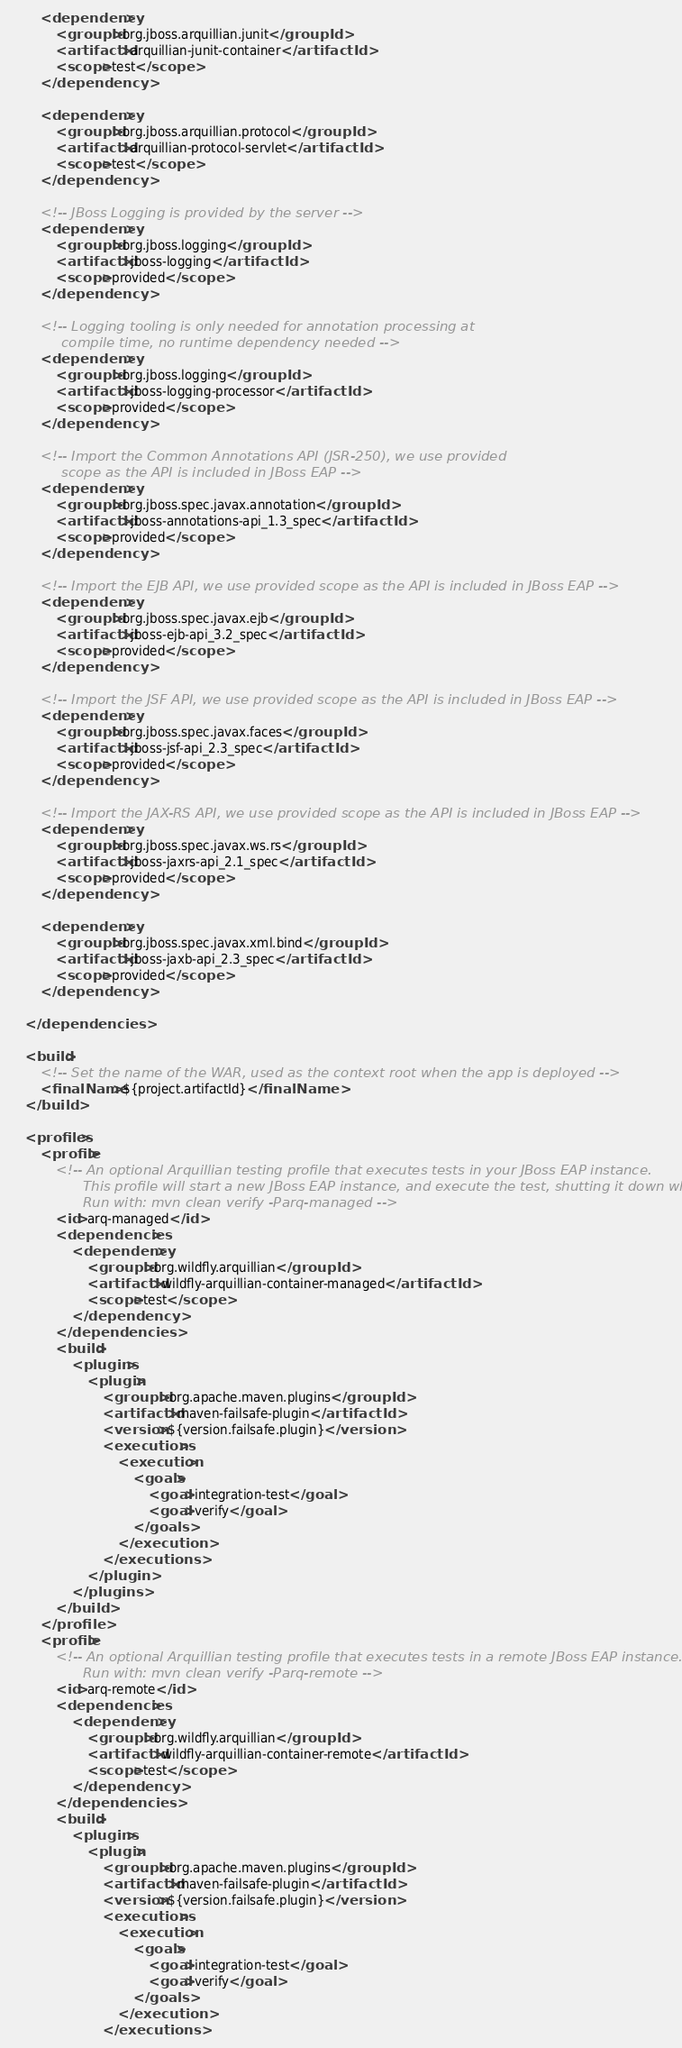<code> <loc_0><loc_0><loc_500><loc_500><_XML_>        <dependency>
            <groupId>org.jboss.arquillian.junit</groupId>
            <artifactId>arquillian-junit-container</artifactId>
            <scope>test</scope>
        </dependency>

        <dependency>
            <groupId>org.jboss.arquillian.protocol</groupId>
            <artifactId>arquillian-protocol-servlet</artifactId>
            <scope>test</scope>
        </dependency>

        <!-- JBoss Logging is provided by the server -->
        <dependency>
            <groupId>org.jboss.logging</groupId>
            <artifactId>jboss-logging</artifactId>
            <scope>provided</scope>
        </dependency>

        <!-- Logging tooling is only needed for annotation processing at
            compile time, no runtime dependency needed -->
        <dependency>
            <groupId>org.jboss.logging</groupId>
            <artifactId>jboss-logging-processor</artifactId>
            <scope>provided</scope>
        </dependency>

        <!-- Import the Common Annotations API (JSR-250), we use provided
            scope as the API is included in JBoss EAP -->
        <dependency>
            <groupId>org.jboss.spec.javax.annotation</groupId>
            <artifactId>jboss-annotations-api_1.3_spec</artifactId>
            <scope>provided</scope>
        </dependency>

        <!-- Import the EJB API, we use provided scope as the API is included in JBoss EAP -->
        <dependency>
            <groupId>org.jboss.spec.javax.ejb</groupId>
            <artifactId>jboss-ejb-api_3.2_spec</artifactId>
            <scope>provided</scope>
        </dependency>

        <!-- Import the JSF API, we use provided scope as the API is included in JBoss EAP -->
        <dependency>
            <groupId>org.jboss.spec.javax.faces</groupId>
            <artifactId>jboss-jsf-api_2.3_spec</artifactId>
            <scope>provided</scope>
        </dependency>

        <!-- Import the JAX-RS API, we use provided scope as the API is included in JBoss EAP -->
        <dependency>
            <groupId>org.jboss.spec.javax.ws.rs</groupId>
            <artifactId>jboss-jaxrs-api_2.1_spec</artifactId>
            <scope>provided</scope>
        </dependency>

        <dependency>
            <groupId>org.jboss.spec.javax.xml.bind</groupId>
            <artifactId>jboss-jaxb-api_2.3_spec</artifactId>
            <scope>provided</scope>
        </dependency>

    </dependencies>

    <build>
        <!-- Set the name of the WAR, used as the context root when the app is deployed -->
        <finalName>${project.artifactId}</finalName>
    </build>

    <profiles>
        <profile>
            <!-- An optional Arquillian testing profile that executes tests in your JBoss EAP instance.
                 This profile will start a new JBoss EAP instance, and execute the test, shutting it down when done.
                 Run with: mvn clean verify -Parq-managed -->
            <id>arq-managed</id>
            <dependencies>
                <dependency>
                    <groupId>org.wildfly.arquillian</groupId>
                    <artifactId>wildfly-arquillian-container-managed</artifactId>
                    <scope>test</scope>
                </dependency>
            </dependencies>
            <build>
                <plugins>
                    <plugin>
                        <groupId>org.apache.maven.plugins</groupId>
                        <artifactId>maven-failsafe-plugin</artifactId>
                        <version>${version.failsafe.plugin}</version>
                        <executions>
                            <execution>
                                <goals>
                                    <goal>integration-test</goal>
                                    <goal>verify</goal>
                                </goals>
                            </execution>
                        </executions>
                    </plugin>
                </plugins>
            </build>
        </profile>
        <profile>
            <!-- An optional Arquillian testing profile that executes tests in a remote JBoss EAP instance.
                 Run with: mvn clean verify -Parq-remote -->
            <id>arq-remote</id>
            <dependencies>
                <dependency>
                    <groupId>org.wildfly.arquillian</groupId>
                    <artifactId>wildfly-arquillian-container-remote</artifactId>
                    <scope>test</scope>
                </dependency>
            </dependencies>
            <build>
                <plugins>
                    <plugin>
                        <groupId>org.apache.maven.plugins</groupId>
                        <artifactId>maven-failsafe-plugin</artifactId>
                        <version>${version.failsafe.plugin}</version>
                        <executions>
                            <execution>
                                <goals>
                                    <goal>integration-test</goal>
                                    <goal>verify</goal>
                                </goals>
                            </execution>
                        </executions></code> 